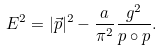Convert formula to latex. <formula><loc_0><loc_0><loc_500><loc_500>E ^ { 2 } = | \vec { p } | ^ { 2 } - \frac { a } { \pi ^ { 2 } } \frac { g ^ { 2 } } { p \circ p } .</formula> 